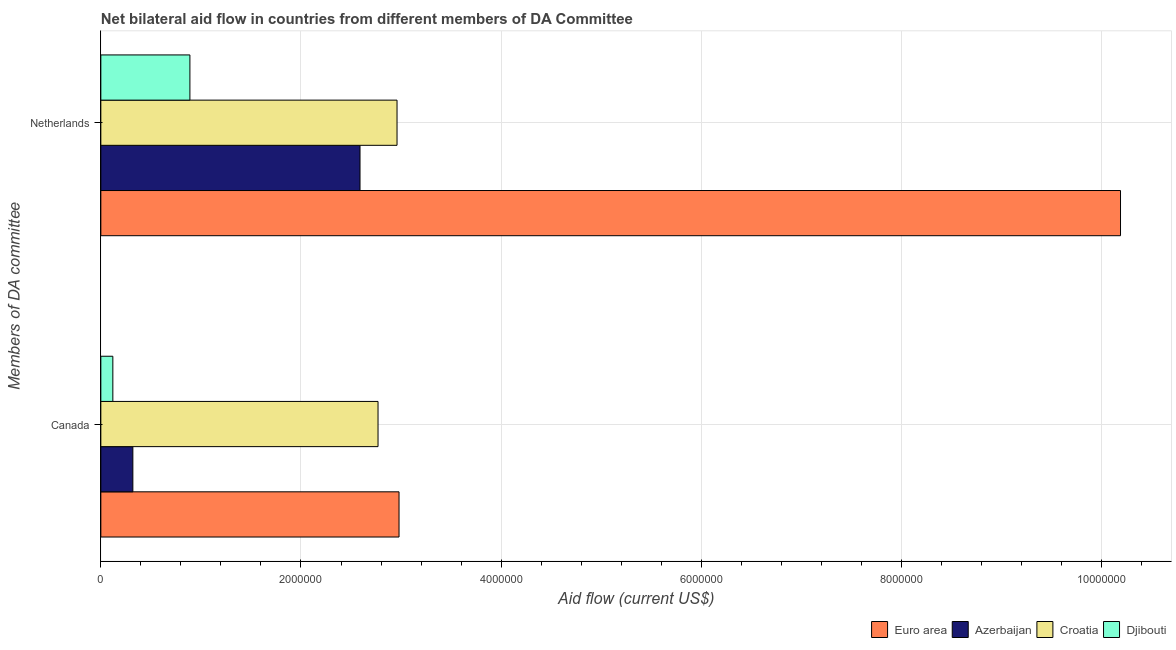How many different coloured bars are there?
Your answer should be compact. 4. Are the number of bars on each tick of the Y-axis equal?
Provide a succinct answer. Yes. How many bars are there on the 2nd tick from the top?
Offer a terse response. 4. How many bars are there on the 2nd tick from the bottom?
Your answer should be very brief. 4. What is the amount of aid given by netherlands in Euro area?
Your answer should be compact. 1.02e+07. Across all countries, what is the maximum amount of aid given by netherlands?
Keep it short and to the point. 1.02e+07. Across all countries, what is the minimum amount of aid given by netherlands?
Keep it short and to the point. 8.90e+05. In which country was the amount of aid given by canada maximum?
Your answer should be very brief. Euro area. In which country was the amount of aid given by canada minimum?
Offer a very short reply. Djibouti. What is the total amount of aid given by netherlands in the graph?
Ensure brevity in your answer.  1.66e+07. What is the difference between the amount of aid given by canada in Euro area and that in Djibouti?
Your answer should be compact. 2.86e+06. What is the difference between the amount of aid given by canada in Azerbaijan and the amount of aid given by netherlands in Djibouti?
Your response must be concise. -5.70e+05. What is the average amount of aid given by canada per country?
Your response must be concise. 1.55e+06. What is the difference between the amount of aid given by canada and amount of aid given by netherlands in Azerbaijan?
Keep it short and to the point. -2.27e+06. What is the ratio of the amount of aid given by netherlands in Euro area to that in Djibouti?
Give a very brief answer. 11.45. What does the 1st bar from the top in Canada represents?
Your response must be concise. Djibouti. What does the 3rd bar from the bottom in Canada represents?
Make the answer very short. Croatia. How many bars are there?
Make the answer very short. 8. Are all the bars in the graph horizontal?
Provide a short and direct response. Yes. What is the difference between two consecutive major ticks on the X-axis?
Make the answer very short. 2.00e+06. Does the graph contain any zero values?
Your answer should be compact. No. Does the graph contain grids?
Provide a succinct answer. Yes. How many legend labels are there?
Provide a short and direct response. 4. How are the legend labels stacked?
Your response must be concise. Horizontal. What is the title of the graph?
Make the answer very short. Net bilateral aid flow in countries from different members of DA Committee. What is the label or title of the X-axis?
Make the answer very short. Aid flow (current US$). What is the label or title of the Y-axis?
Give a very brief answer. Members of DA committee. What is the Aid flow (current US$) of Euro area in Canada?
Offer a terse response. 2.98e+06. What is the Aid flow (current US$) in Azerbaijan in Canada?
Ensure brevity in your answer.  3.20e+05. What is the Aid flow (current US$) of Croatia in Canada?
Your answer should be compact. 2.77e+06. What is the Aid flow (current US$) of Djibouti in Canada?
Offer a very short reply. 1.20e+05. What is the Aid flow (current US$) in Euro area in Netherlands?
Make the answer very short. 1.02e+07. What is the Aid flow (current US$) in Azerbaijan in Netherlands?
Provide a short and direct response. 2.59e+06. What is the Aid flow (current US$) of Croatia in Netherlands?
Offer a very short reply. 2.96e+06. What is the Aid flow (current US$) of Djibouti in Netherlands?
Your answer should be very brief. 8.90e+05. Across all Members of DA committee, what is the maximum Aid flow (current US$) of Euro area?
Ensure brevity in your answer.  1.02e+07. Across all Members of DA committee, what is the maximum Aid flow (current US$) of Azerbaijan?
Make the answer very short. 2.59e+06. Across all Members of DA committee, what is the maximum Aid flow (current US$) in Croatia?
Your answer should be compact. 2.96e+06. Across all Members of DA committee, what is the maximum Aid flow (current US$) in Djibouti?
Your answer should be very brief. 8.90e+05. Across all Members of DA committee, what is the minimum Aid flow (current US$) of Euro area?
Your answer should be compact. 2.98e+06. Across all Members of DA committee, what is the minimum Aid flow (current US$) in Azerbaijan?
Your response must be concise. 3.20e+05. Across all Members of DA committee, what is the minimum Aid flow (current US$) in Croatia?
Your answer should be compact. 2.77e+06. Across all Members of DA committee, what is the minimum Aid flow (current US$) in Djibouti?
Offer a terse response. 1.20e+05. What is the total Aid flow (current US$) in Euro area in the graph?
Make the answer very short. 1.32e+07. What is the total Aid flow (current US$) of Azerbaijan in the graph?
Give a very brief answer. 2.91e+06. What is the total Aid flow (current US$) in Croatia in the graph?
Offer a terse response. 5.73e+06. What is the total Aid flow (current US$) in Djibouti in the graph?
Keep it short and to the point. 1.01e+06. What is the difference between the Aid flow (current US$) of Euro area in Canada and that in Netherlands?
Your answer should be very brief. -7.21e+06. What is the difference between the Aid flow (current US$) in Azerbaijan in Canada and that in Netherlands?
Ensure brevity in your answer.  -2.27e+06. What is the difference between the Aid flow (current US$) in Djibouti in Canada and that in Netherlands?
Your answer should be compact. -7.70e+05. What is the difference between the Aid flow (current US$) in Euro area in Canada and the Aid flow (current US$) in Azerbaijan in Netherlands?
Keep it short and to the point. 3.90e+05. What is the difference between the Aid flow (current US$) in Euro area in Canada and the Aid flow (current US$) in Croatia in Netherlands?
Make the answer very short. 2.00e+04. What is the difference between the Aid flow (current US$) in Euro area in Canada and the Aid flow (current US$) in Djibouti in Netherlands?
Offer a very short reply. 2.09e+06. What is the difference between the Aid flow (current US$) in Azerbaijan in Canada and the Aid flow (current US$) in Croatia in Netherlands?
Give a very brief answer. -2.64e+06. What is the difference between the Aid flow (current US$) of Azerbaijan in Canada and the Aid flow (current US$) of Djibouti in Netherlands?
Your answer should be very brief. -5.70e+05. What is the difference between the Aid flow (current US$) in Croatia in Canada and the Aid flow (current US$) in Djibouti in Netherlands?
Make the answer very short. 1.88e+06. What is the average Aid flow (current US$) in Euro area per Members of DA committee?
Offer a terse response. 6.58e+06. What is the average Aid flow (current US$) of Azerbaijan per Members of DA committee?
Provide a succinct answer. 1.46e+06. What is the average Aid flow (current US$) of Croatia per Members of DA committee?
Your answer should be compact. 2.86e+06. What is the average Aid flow (current US$) of Djibouti per Members of DA committee?
Keep it short and to the point. 5.05e+05. What is the difference between the Aid flow (current US$) of Euro area and Aid flow (current US$) of Azerbaijan in Canada?
Your answer should be compact. 2.66e+06. What is the difference between the Aid flow (current US$) in Euro area and Aid flow (current US$) in Djibouti in Canada?
Your answer should be very brief. 2.86e+06. What is the difference between the Aid flow (current US$) in Azerbaijan and Aid flow (current US$) in Croatia in Canada?
Your answer should be very brief. -2.45e+06. What is the difference between the Aid flow (current US$) in Croatia and Aid flow (current US$) in Djibouti in Canada?
Make the answer very short. 2.65e+06. What is the difference between the Aid flow (current US$) in Euro area and Aid flow (current US$) in Azerbaijan in Netherlands?
Your answer should be very brief. 7.60e+06. What is the difference between the Aid flow (current US$) of Euro area and Aid flow (current US$) of Croatia in Netherlands?
Give a very brief answer. 7.23e+06. What is the difference between the Aid flow (current US$) of Euro area and Aid flow (current US$) of Djibouti in Netherlands?
Make the answer very short. 9.30e+06. What is the difference between the Aid flow (current US$) in Azerbaijan and Aid flow (current US$) in Croatia in Netherlands?
Make the answer very short. -3.70e+05. What is the difference between the Aid flow (current US$) in Azerbaijan and Aid flow (current US$) in Djibouti in Netherlands?
Ensure brevity in your answer.  1.70e+06. What is the difference between the Aid flow (current US$) in Croatia and Aid flow (current US$) in Djibouti in Netherlands?
Your response must be concise. 2.07e+06. What is the ratio of the Aid flow (current US$) in Euro area in Canada to that in Netherlands?
Ensure brevity in your answer.  0.29. What is the ratio of the Aid flow (current US$) of Azerbaijan in Canada to that in Netherlands?
Offer a terse response. 0.12. What is the ratio of the Aid flow (current US$) in Croatia in Canada to that in Netherlands?
Your answer should be very brief. 0.94. What is the ratio of the Aid flow (current US$) in Djibouti in Canada to that in Netherlands?
Your response must be concise. 0.13. What is the difference between the highest and the second highest Aid flow (current US$) in Euro area?
Make the answer very short. 7.21e+06. What is the difference between the highest and the second highest Aid flow (current US$) of Azerbaijan?
Keep it short and to the point. 2.27e+06. What is the difference between the highest and the second highest Aid flow (current US$) of Croatia?
Offer a very short reply. 1.90e+05. What is the difference between the highest and the second highest Aid flow (current US$) in Djibouti?
Provide a succinct answer. 7.70e+05. What is the difference between the highest and the lowest Aid flow (current US$) in Euro area?
Provide a short and direct response. 7.21e+06. What is the difference between the highest and the lowest Aid flow (current US$) of Azerbaijan?
Provide a succinct answer. 2.27e+06. What is the difference between the highest and the lowest Aid flow (current US$) of Croatia?
Offer a terse response. 1.90e+05. What is the difference between the highest and the lowest Aid flow (current US$) of Djibouti?
Provide a succinct answer. 7.70e+05. 